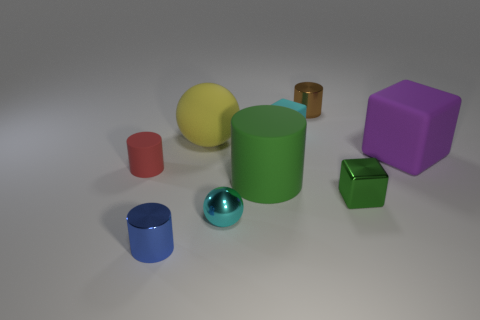Subtract all small red cylinders. How many cylinders are left? 3 Subtract 2 cylinders. How many cylinders are left? 2 Subtract all brown cylinders. How many cylinders are left? 3 Subtract all blue cylinders. Subtract all green balls. How many cylinders are left? 3 Subtract all balls. How many objects are left? 7 Subtract 0 red blocks. How many objects are left? 9 Subtract all green matte objects. Subtract all small red cylinders. How many objects are left? 7 Add 3 yellow things. How many yellow things are left? 4 Add 5 large red rubber cylinders. How many large red rubber cylinders exist? 5 